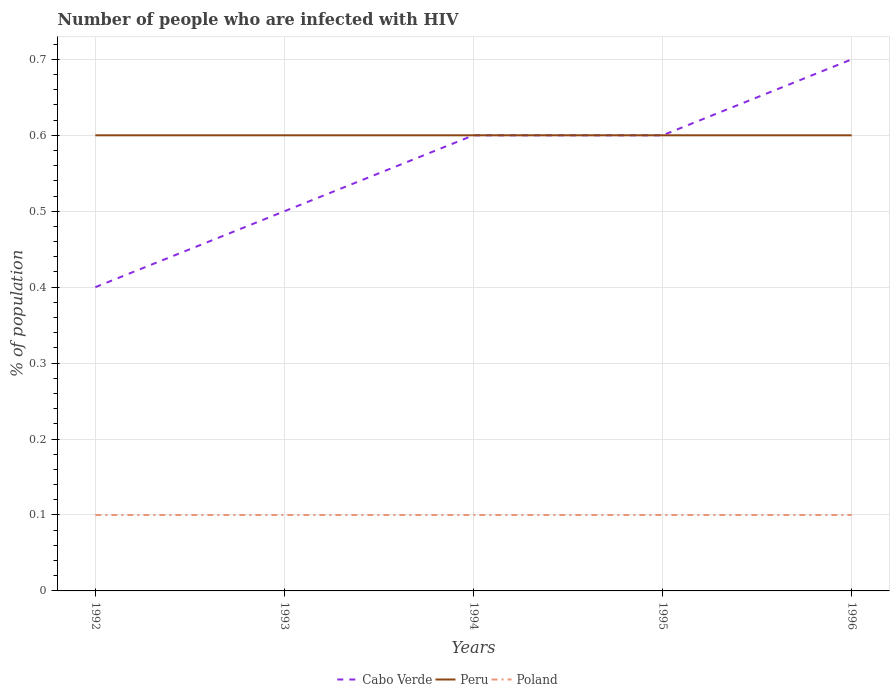How many different coloured lines are there?
Make the answer very short. 3. Does the line corresponding to Poland intersect with the line corresponding to Cabo Verde?
Your response must be concise. No. Across all years, what is the maximum percentage of HIV infected population in in Poland?
Provide a succinct answer. 0.1. In which year was the percentage of HIV infected population in in Poland maximum?
Make the answer very short. 1992. What is the total percentage of HIV infected population in in Poland in the graph?
Provide a short and direct response. 0. What is the difference between the highest and the lowest percentage of HIV infected population in in Poland?
Ensure brevity in your answer.  0. Is the percentage of HIV infected population in in Peru strictly greater than the percentage of HIV infected population in in Poland over the years?
Make the answer very short. No. How many lines are there?
Make the answer very short. 3. How many years are there in the graph?
Your answer should be very brief. 5. What is the difference between two consecutive major ticks on the Y-axis?
Your answer should be very brief. 0.1. Are the values on the major ticks of Y-axis written in scientific E-notation?
Your answer should be compact. No. Does the graph contain any zero values?
Your response must be concise. No. Where does the legend appear in the graph?
Provide a succinct answer. Bottom center. How are the legend labels stacked?
Provide a succinct answer. Horizontal. What is the title of the graph?
Offer a terse response. Number of people who are infected with HIV. Does "Other small states" appear as one of the legend labels in the graph?
Give a very brief answer. No. What is the label or title of the X-axis?
Offer a very short reply. Years. What is the label or title of the Y-axis?
Offer a very short reply. % of population. What is the % of population of Cabo Verde in 1993?
Make the answer very short. 0.5. What is the % of population in Peru in 1993?
Your response must be concise. 0.6. What is the % of population in Poland in 1993?
Ensure brevity in your answer.  0.1. What is the % of population of Cabo Verde in 1994?
Provide a short and direct response. 0.6. What is the % of population in Peru in 1994?
Your answer should be compact. 0.6. What is the % of population of Cabo Verde in 1995?
Ensure brevity in your answer.  0.6. What is the % of population in Peru in 1995?
Your answer should be compact. 0.6. What is the % of population of Cabo Verde in 1996?
Your answer should be very brief. 0.7. What is the % of population of Poland in 1996?
Your response must be concise. 0.1. Across all years, what is the maximum % of population in Peru?
Your answer should be compact. 0.6. Across all years, what is the maximum % of population in Poland?
Your response must be concise. 0.1. Across all years, what is the minimum % of population of Peru?
Provide a succinct answer. 0.6. What is the total % of population of Cabo Verde in the graph?
Your answer should be compact. 2.8. What is the difference between the % of population in Poland in 1992 and that in 1993?
Make the answer very short. 0. What is the difference between the % of population of Cabo Verde in 1992 and that in 1994?
Your answer should be very brief. -0.2. What is the difference between the % of population in Peru in 1992 and that in 1994?
Your answer should be very brief. 0. What is the difference between the % of population of Poland in 1992 and that in 1994?
Your answer should be very brief. 0. What is the difference between the % of population of Cabo Verde in 1992 and that in 1995?
Provide a short and direct response. -0.2. What is the difference between the % of population of Poland in 1992 and that in 1995?
Offer a very short reply. 0. What is the difference between the % of population in Cabo Verde in 1992 and that in 1996?
Ensure brevity in your answer.  -0.3. What is the difference between the % of population of Cabo Verde in 1993 and that in 1994?
Make the answer very short. -0.1. What is the difference between the % of population of Poland in 1993 and that in 1994?
Ensure brevity in your answer.  0. What is the difference between the % of population of Peru in 1993 and that in 1995?
Provide a short and direct response. 0. What is the difference between the % of population in Peru in 1993 and that in 1996?
Your response must be concise. 0. What is the difference between the % of population of Peru in 1994 and that in 1995?
Provide a succinct answer. 0. What is the difference between the % of population in Cabo Verde in 1994 and that in 1996?
Your answer should be compact. -0.1. What is the difference between the % of population of Cabo Verde in 1995 and that in 1996?
Your answer should be very brief. -0.1. What is the difference between the % of population in Poland in 1995 and that in 1996?
Provide a succinct answer. 0. What is the difference between the % of population in Cabo Verde in 1992 and the % of population in Poland in 1993?
Your response must be concise. 0.3. What is the difference between the % of population in Peru in 1992 and the % of population in Poland in 1993?
Offer a terse response. 0.5. What is the difference between the % of population of Cabo Verde in 1992 and the % of population of Peru in 1995?
Offer a terse response. -0.2. What is the difference between the % of population in Cabo Verde in 1992 and the % of population in Poland in 1995?
Your response must be concise. 0.3. What is the difference between the % of population of Peru in 1992 and the % of population of Poland in 1996?
Make the answer very short. 0.5. What is the difference between the % of population of Cabo Verde in 1993 and the % of population of Peru in 1994?
Your answer should be very brief. -0.1. What is the difference between the % of population of Peru in 1993 and the % of population of Poland in 1994?
Give a very brief answer. 0.5. What is the difference between the % of population of Cabo Verde in 1993 and the % of population of Poland in 1995?
Ensure brevity in your answer.  0.4. What is the difference between the % of population in Peru in 1993 and the % of population in Poland in 1995?
Provide a short and direct response. 0.5. What is the difference between the % of population of Peru in 1993 and the % of population of Poland in 1996?
Your response must be concise. 0.5. What is the difference between the % of population in Cabo Verde in 1994 and the % of population in Poland in 1995?
Your answer should be very brief. 0.5. What is the difference between the % of population of Peru in 1994 and the % of population of Poland in 1996?
Offer a very short reply. 0.5. What is the difference between the % of population in Peru in 1995 and the % of population in Poland in 1996?
Provide a succinct answer. 0.5. What is the average % of population in Cabo Verde per year?
Provide a succinct answer. 0.56. What is the average % of population of Poland per year?
Offer a terse response. 0.1. In the year 1992, what is the difference between the % of population of Peru and % of population of Poland?
Offer a very short reply. 0.5. In the year 1993, what is the difference between the % of population in Cabo Verde and % of population in Poland?
Give a very brief answer. 0.4. In the year 1994, what is the difference between the % of population of Peru and % of population of Poland?
Make the answer very short. 0.5. What is the ratio of the % of population of Cabo Verde in 1992 to that in 1994?
Your answer should be very brief. 0.67. What is the ratio of the % of population in Poland in 1992 to that in 1994?
Your answer should be very brief. 1. What is the ratio of the % of population in Poland in 1992 to that in 1995?
Offer a terse response. 1. What is the ratio of the % of population in Poland in 1992 to that in 1996?
Give a very brief answer. 1. What is the ratio of the % of population in Cabo Verde in 1993 to that in 1994?
Ensure brevity in your answer.  0.83. What is the ratio of the % of population in Peru in 1993 to that in 1994?
Give a very brief answer. 1. What is the ratio of the % of population of Cabo Verde in 1993 to that in 1995?
Provide a short and direct response. 0.83. What is the ratio of the % of population of Peru in 1993 to that in 1995?
Your answer should be compact. 1. What is the ratio of the % of population of Cabo Verde in 1993 to that in 1996?
Your answer should be very brief. 0.71. What is the ratio of the % of population in Poland in 1993 to that in 1996?
Provide a short and direct response. 1. What is the ratio of the % of population in Cabo Verde in 1994 to that in 1996?
Provide a succinct answer. 0.86. What is the ratio of the % of population of Poland in 1994 to that in 1996?
Offer a very short reply. 1. What is the difference between the highest and the second highest % of population in Cabo Verde?
Your answer should be compact. 0.1. What is the difference between the highest and the second highest % of population of Poland?
Make the answer very short. 0. What is the difference between the highest and the lowest % of population of Cabo Verde?
Keep it short and to the point. 0.3. What is the difference between the highest and the lowest % of population in Peru?
Your response must be concise. 0. 